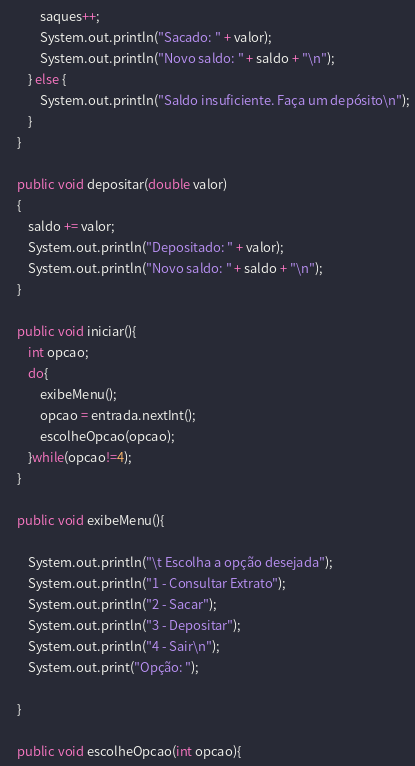<code> <loc_0><loc_0><loc_500><loc_500><_JavaScript_>            saques++;
            System.out.println("Sacado: " + valor);
            System.out.println("Novo saldo: " + saldo + "\n");
        } else {
            System.out.println("Saldo insuficiente. Faça um depósito\n");
        }
    }
    
    public void depositar(double valor)
    {
        saldo += valor;
        System.out.println("Depositado: " + valor);
        System.out.println("Novo saldo: " + saldo + "\n");
    }
    
    public void iniciar(){
        int opcao;
        do{
            exibeMenu();
            opcao = entrada.nextInt();
            escolheOpcao(opcao);
        }while(opcao!=4);
    }
    
    public void exibeMenu(){
        
        System.out.println("\t Escolha a opção desejada");
        System.out.println("1 - Consultar Extrato");
        System.out.println("2 - Sacar");
        System.out.println("3 - Depositar");
        System.out.println("4 - Sair\n");
        System.out.print("Opção: ");
        
    }
    
    public void escolheOpcao(int opcao){</code> 